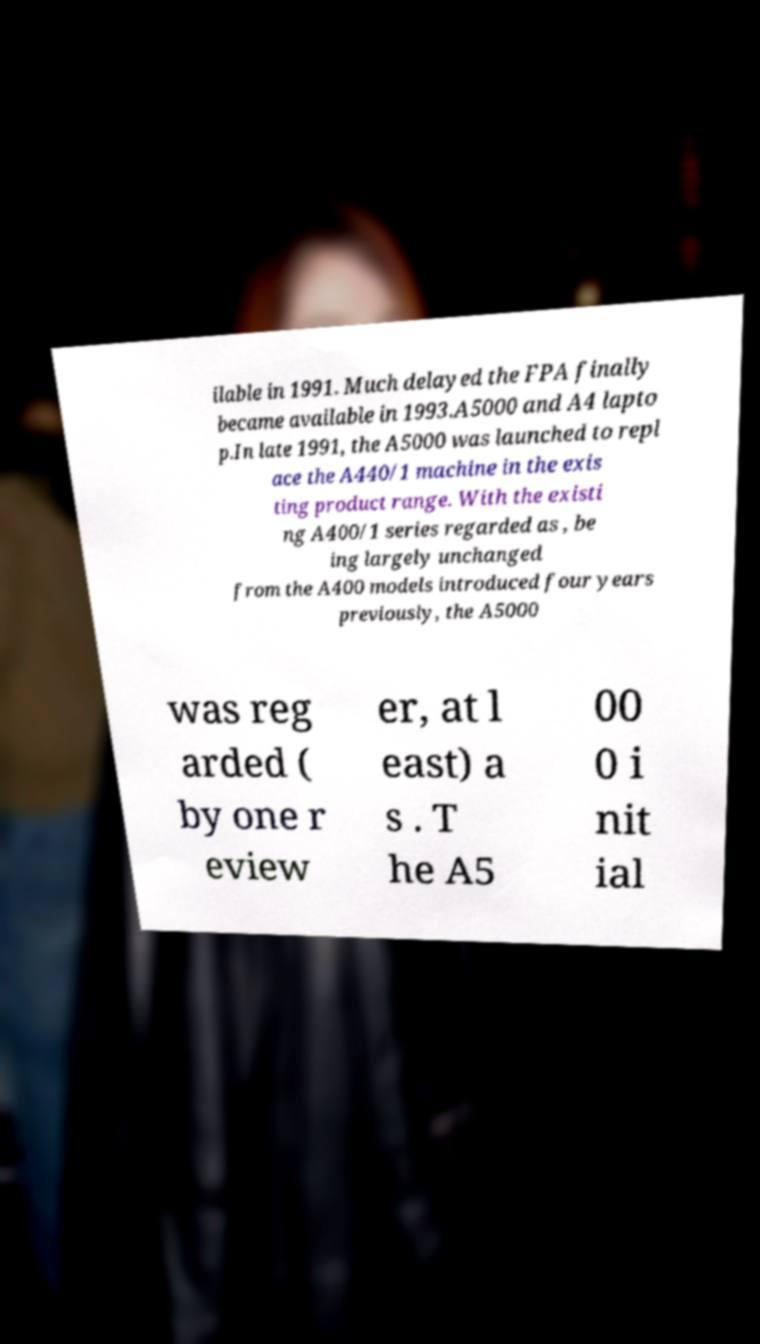What messages or text are displayed in this image? I need them in a readable, typed format. ilable in 1991. Much delayed the FPA finally became available in 1993.A5000 and A4 lapto p.In late 1991, the A5000 was launched to repl ace the A440/1 machine in the exis ting product range. With the existi ng A400/1 series regarded as , be ing largely unchanged from the A400 models introduced four years previously, the A5000 was reg arded ( by one r eview er, at l east) a s . T he A5 00 0 i nit ial 